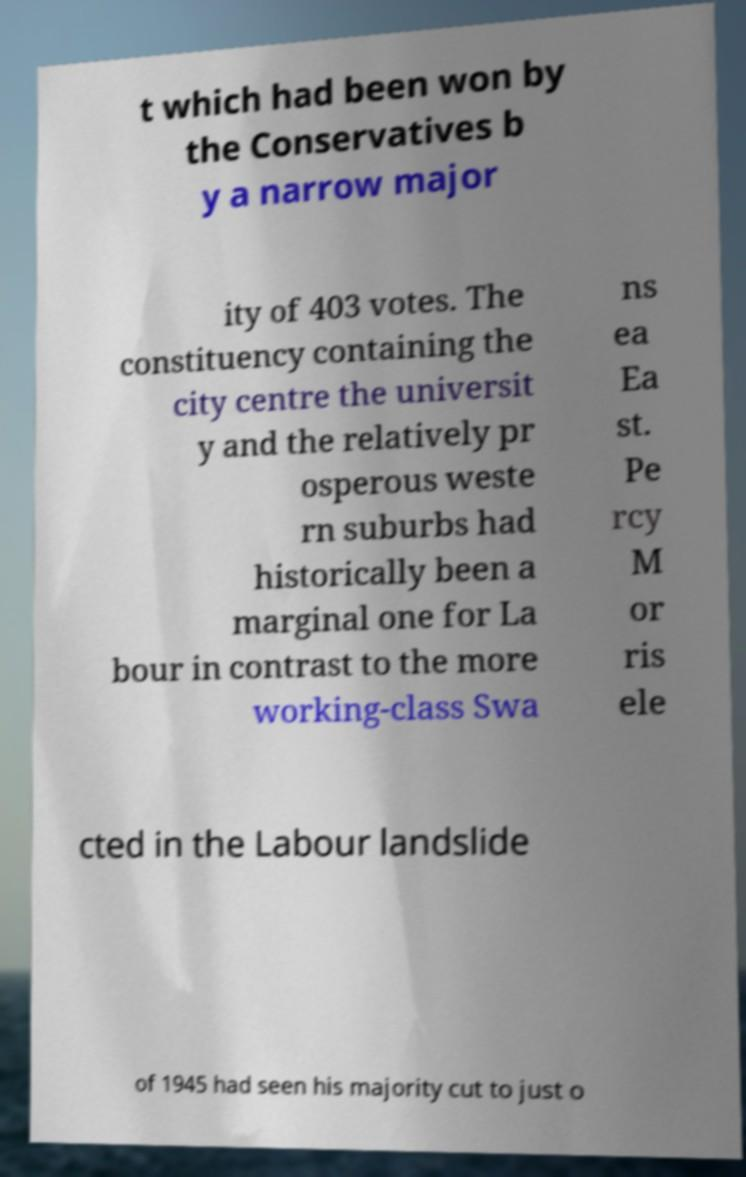For documentation purposes, I need the text within this image transcribed. Could you provide that? t which had been won by the Conservatives b y a narrow major ity of 403 votes. The constituency containing the city centre the universit y and the relatively pr osperous weste rn suburbs had historically been a marginal one for La bour in contrast to the more working-class Swa ns ea Ea st. Pe rcy M or ris ele cted in the Labour landslide of 1945 had seen his majority cut to just o 